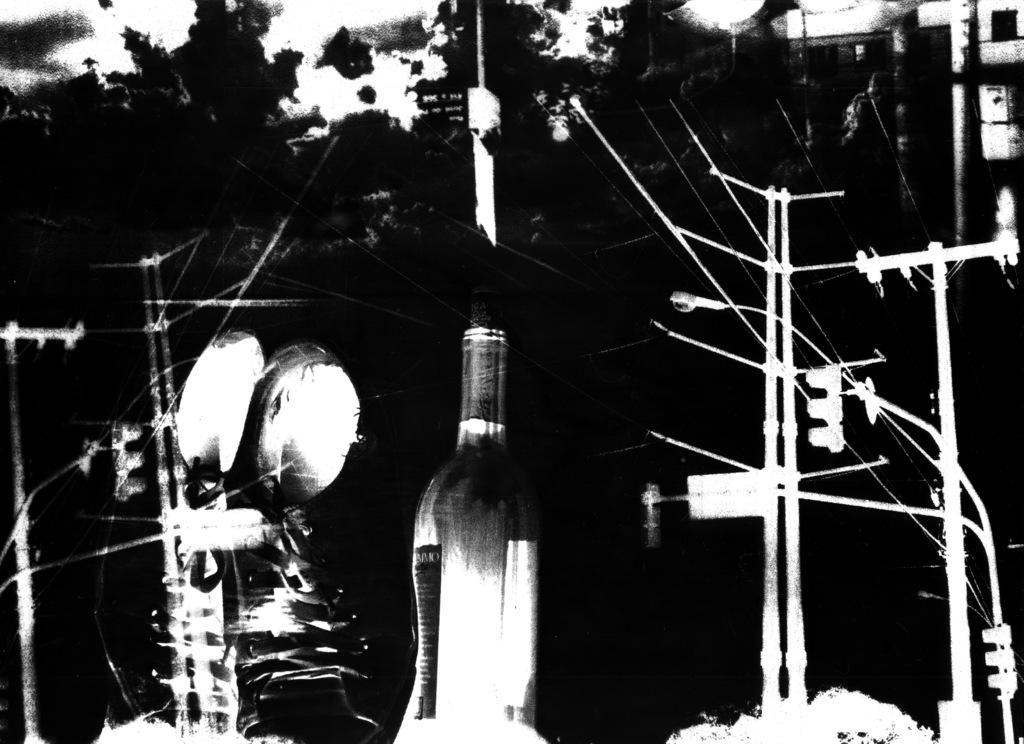What is located in the foreground of the image? In the foreground of the image, there is a bottle, poles, cables, and trees. Can you describe the objects in the foreground? The bottle is a standalone object, while the poles, cables, and trees are interconnected. What can be seen on the right side of the image? There appear to be buildings on the right side of the image. How many ants can be seen crawling on the bottle in the image? There are no ants visible on the bottle in the image. What type of air is present in the image? The image does not depict a specific type of air; it simply shows a scene with various objects and structures. 